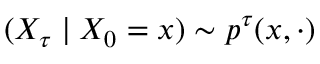<formula> <loc_0><loc_0><loc_500><loc_500>( X _ { \tau } | X _ { 0 } = x ) \sim p ^ { \tau } ( x , \cdot )</formula> 